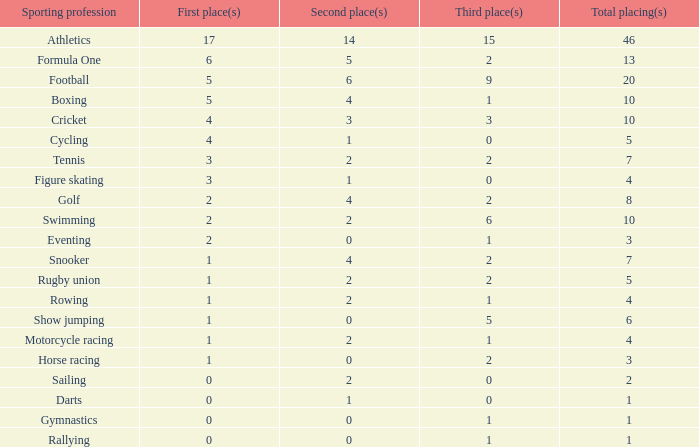How many second place showings does snooker have? 4.0. 